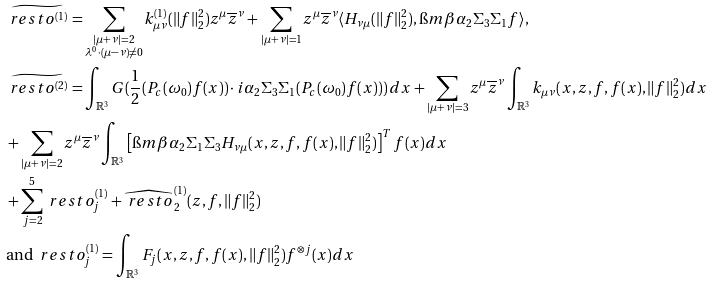Convert formula to latex. <formula><loc_0><loc_0><loc_500><loc_500>& \widetilde { \ r e s t o ^ { ( 1 ) } } = \sum _ { \substack { | \mu + \nu | = 2 \\ \lambda ^ { 0 } \cdot ( \mu - \nu ) \neq 0 } } k _ { \mu \nu } ^ { ( 1 ) } ( \| f \| _ { 2 } ^ { 2 } ) z ^ { \mu } \overline { z } ^ { \nu } + \sum _ { | \mu + \nu | = 1 } z ^ { \mu } \overline { z } ^ { \nu } \langle H _ { \nu \mu } ( \| f \| _ { 2 } ^ { 2 } ) , \i m \beta \alpha _ { 2 } \Sigma _ { 3 } \Sigma _ { 1 } f \rangle , \\ & \widetilde { \ r e s t o ^ { ( 2 ) } } = \int _ { \mathbb { R } ^ { 3 } } G ( \frac { 1 } { 2 } ( P _ { c } ( \omega _ { 0 } ) f ( x ) ) \cdot i \alpha _ { 2 } \Sigma _ { 3 } \Sigma _ { 1 } ( P _ { c } ( \omega _ { 0 } ) f ( x ) ) ) \, d x + \sum _ { | \mu + \nu | = 3 } z ^ { \mu } \overline { z } ^ { \nu } \int _ { \mathbb { R } ^ { 3 } } k _ { \mu \nu } ( x , z , f , f ( x ) , \| f \| _ { 2 } ^ { 2 } ) d x \\ & + \sum _ { | \mu + \nu | = 2 } z ^ { \mu } \overline { z } ^ { \nu } \int _ { \mathbb { R } ^ { 3 } } \left [ \i m \beta \alpha _ { 2 } \Sigma _ { 1 } \Sigma _ { 3 } H _ { \nu \mu } ( x , z , f , f ( x ) , \| f \| _ { 2 } ^ { 2 } ) \right ] ^ { T } f ( x ) d x \\ & + \sum _ { j = 2 } ^ { 5 } \ r e s t o ^ { ( 1 ) } _ { j } + \widehat { \ r e s t o } ^ { ( 1 ) } _ { 2 } ( z , f , \| f \| _ { 2 } ^ { 2 } ) \\ & \text {and } \ r e s t o ^ { ( 1 ) } _ { j } = \int _ { \mathbb { R } ^ { 3 } } F _ { j } ( x , z , f , f ( x ) , \| f \| _ { 2 } ^ { 2 } ) f ^ { \otimes j } ( x ) d x</formula> 